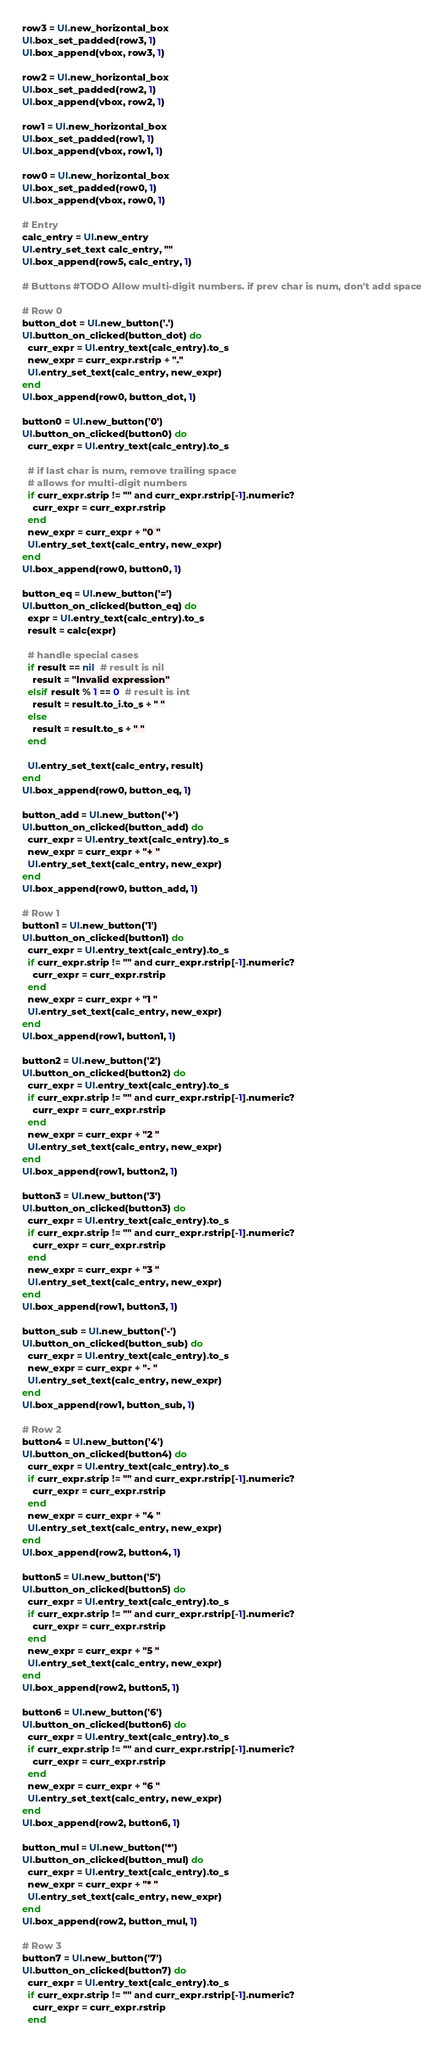<code> <loc_0><loc_0><loc_500><loc_500><_Ruby_>row3 = UI.new_horizontal_box
UI.box_set_padded(row3, 1)
UI.box_append(vbox, row3, 1)

row2 = UI.new_horizontal_box
UI.box_set_padded(row2, 1)
UI.box_append(vbox, row2, 1)

row1 = UI.new_horizontal_box
UI.box_set_padded(row1, 1)
UI.box_append(vbox, row1, 1)

row0 = UI.new_horizontal_box
UI.box_set_padded(row0, 1)
UI.box_append(vbox, row0, 1)

# Entry
calc_entry = UI.new_entry
UI.entry_set_text calc_entry, ""
UI.box_append(row5, calc_entry, 1)

# Buttons #TODO Allow multi-digit numbers. if prev char is num, don't add space

# Row 0
button_dot = UI.new_button('.')
UI.button_on_clicked(button_dot) do
  curr_expr = UI.entry_text(calc_entry).to_s
  new_expr = curr_expr.rstrip + "."
  UI.entry_set_text(calc_entry, new_expr)
end
UI.box_append(row0, button_dot, 1)

button0 = UI.new_button('0')
UI.button_on_clicked(button0) do
  curr_expr = UI.entry_text(calc_entry).to_s

  # if last char is num, remove trailing space
  # allows for multi-digit numbers
  if curr_expr.strip != "" and curr_expr.rstrip[-1].numeric?
    curr_expr = curr_expr.rstrip
  end
  new_expr = curr_expr + "0 "
  UI.entry_set_text(calc_entry, new_expr)
end
UI.box_append(row0, button0, 1)

button_eq = UI.new_button('=')
UI.button_on_clicked(button_eq) do
  expr = UI.entry_text(calc_entry).to_s
  result = calc(expr)

  # handle special cases
  if result == nil  # result is nil
    result = "Invalid expression"
  elsif result % 1 == 0  # result is int
    result = result.to_i.to_s + " "
  else
    result = result.to_s + " "
  end

  UI.entry_set_text(calc_entry, result)
end
UI.box_append(row0, button_eq, 1)

button_add = UI.new_button('+')
UI.button_on_clicked(button_add) do
  curr_expr = UI.entry_text(calc_entry).to_s
  new_expr = curr_expr + "+ "
  UI.entry_set_text(calc_entry, new_expr)
end
UI.box_append(row0, button_add, 1)

# Row 1
button1 = UI.new_button('1')
UI.button_on_clicked(button1) do
  curr_expr = UI.entry_text(calc_entry).to_s
  if curr_expr.strip != "" and curr_expr.rstrip[-1].numeric?
    curr_expr = curr_expr.rstrip
  end
  new_expr = curr_expr + "1 "
  UI.entry_set_text(calc_entry, new_expr)
end
UI.box_append(row1, button1, 1)

button2 = UI.new_button('2')
UI.button_on_clicked(button2) do
  curr_expr = UI.entry_text(calc_entry).to_s
  if curr_expr.strip != "" and curr_expr.rstrip[-1].numeric?
    curr_expr = curr_expr.rstrip
  end
  new_expr = curr_expr + "2 "
  UI.entry_set_text(calc_entry, new_expr)
end
UI.box_append(row1, button2, 1)

button3 = UI.new_button('3')
UI.button_on_clicked(button3) do
  curr_expr = UI.entry_text(calc_entry).to_s
  if curr_expr.strip != "" and curr_expr.rstrip[-1].numeric?
    curr_expr = curr_expr.rstrip
  end
  new_expr = curr_expr + "3 "
  UI.entry_set_text(calc_entry, new_expr)
end
UI.box_append(row1, button3, 1)

button_sub = UI.new_button('-')
UI.button_on_clicked(button_sub) do
  curr_expr = UI.entry_text(calc_entry).to_s
  new_expr = curr_expr + "- "
  UI.entry_set_text(calc_entry, new_expr)
end
UI.box_append(row1, button_sub, 1)

# Row 2
button4 = UI.new_button('4')
UI.button_on_clicked(button4) do
  curr_expr = UI.entry_text(calc_entry).to_s
  if curr_expr.strip != "" and curr_expr.rstrip[-1].numeric?
    curr_expr = curr_expr.rstrip
  end
  new_expr = curr_expr + "4 "
  UI.entry_set_text(calc_entry, new_expr)
end
UI.box_append(row2, button4, 1)

button5 = UI.new_button('5')
UI.button_on_clicked(button5) do
  curr_expr = UI.entry_text(calc_entry).to_s
  if curr_expr.strip != "" and curr_expr.rstrip[-1].numeric?
    curr_expr = curr_expr.rstrip
  end
  new_expr = curr_expr + "5 "
  UI.entry_set_text(calc_entry, new_expr)
end
UI.box_append(row2, button5, 1)

button6 = UI.new_button('6')
UI.button_on_clicked(button6) do
  curr_expr = UI.entry_text(calc_entry).to_s
  if curr_expr.strip != "" and curr_expr.rstrip[-1].numeric?
    curr_expr = curr_expr.rstrip
  end
  new_expr = curr_expr + "6 "
  UI.entry_set_text(calc_entry, new_expr)
end
UI.box_append(row2, button6, 1)

button_mul = UI.new_button('*')
UI.button_on_clicked(button_mul) do
  curr_expr = UI.entry_text(calc_entry).to_s
  new_expr = curr_expr + "* "
  UI.entry_set_text(calc_entry, new_expr)
end
UI.box_append(row2, button_mul, 1)

# Row 3
button7 = UI.new_button('7')
UI.button_on_clicked(button7) do
  curr_expr = UI.entry_text(calc_entry).to_s
  if curr_expr.strip != "" and curr_expr.rstrip[-1].numeric?
    curr_expr = curr_expr.rstrip
  end</code> 